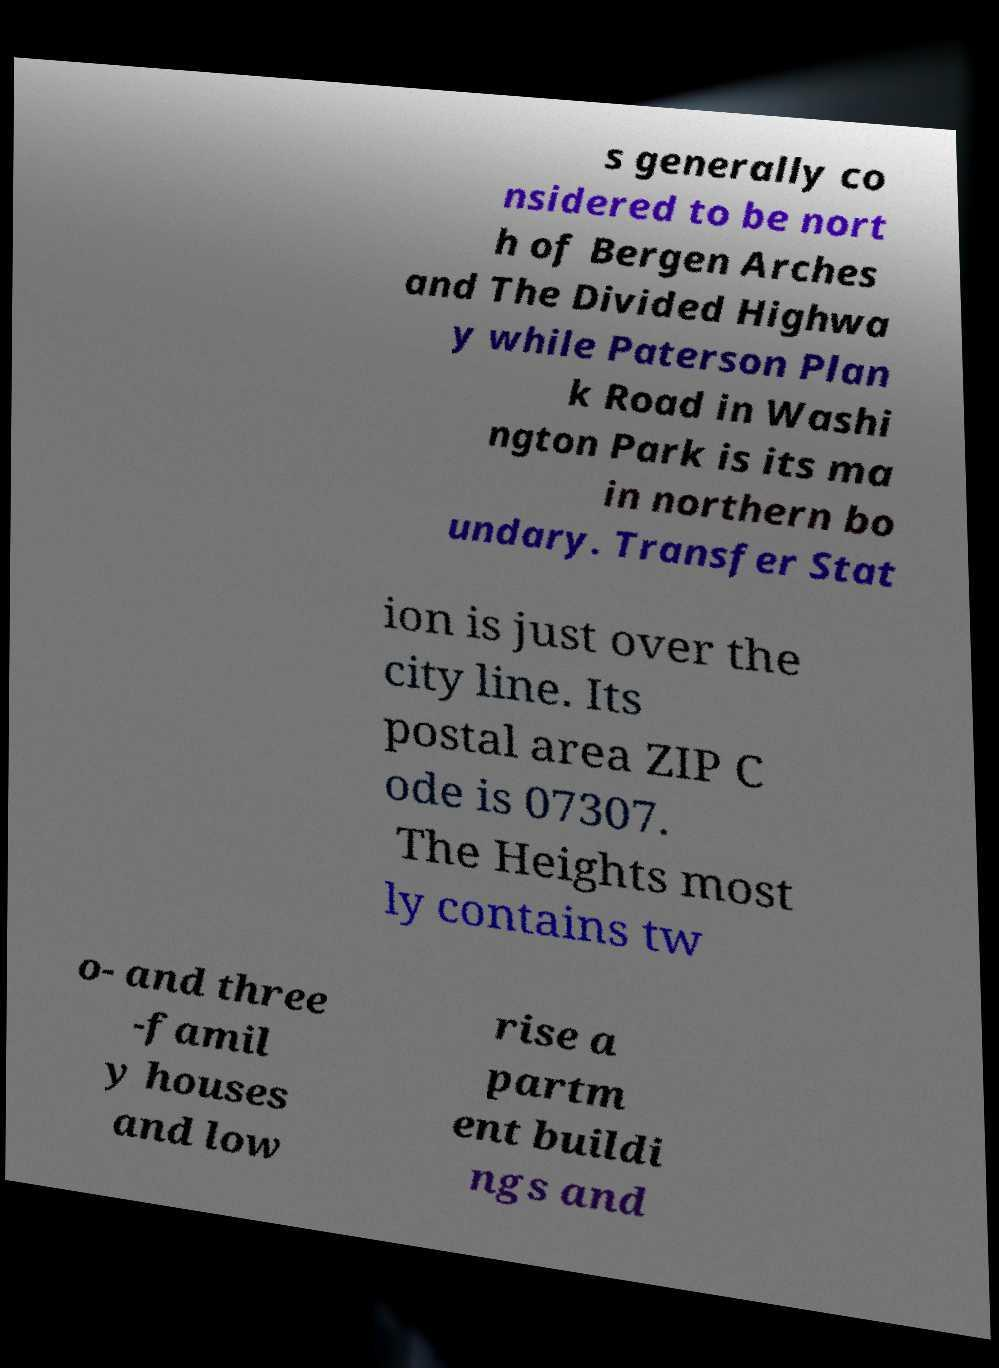Can you accurately transcribe the text from the provided image for me? s generally co nsidered to be nort h of Bergen Arches and The Divided Highwa y while Paterson Plan k Road in Washi ngton Park is its ma in northern bo undary. Transfer Stat ion is just over the city line. Its postal area ZIP C ode is 07307. The Heights most ly contains tw o- and three -famil y houses and low rise a partm ent buildi ngs and 